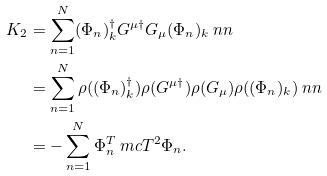Convert formula to latex. <formula><loc_0><loc_0><loc_500><loc_500>K _ { 2 } & = \sum _ { n = 1 } ^ { N } ( \Phi _ { n } ) _ { k } ^ { \dag } G ^ { \mu \dag } G _ { \mu } ( \Phi _ { n } ) _ { k } \ n n \\ & = \sum _ { n = 1 } ^ { N } \rho ( ( \Phi _ { n } ) _ { k } ^ { \dag } ) \rho ( G ^ { \mu \dag } ) \rho ( G _ { \mu } ) \rho ( ( \Phi _ { n } ) _ { k } ) \ n n \\ & = - \sum _ { n = 1 } ^ { N } \Phi _ { n } ^ { T } \ m c { T } ^ { 2 } \Phi _ { n } .</formula> 